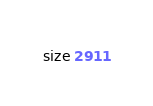Convert code to text. <code><loc_0><loc_0><loc_500><loc_500><_C++_>size 2911
</code> 